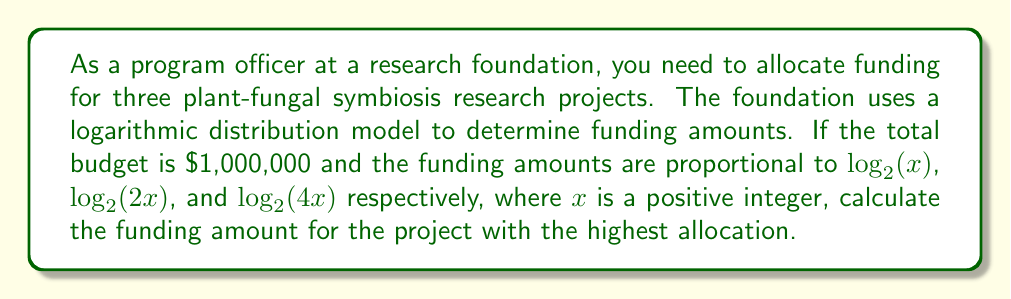Could you help me with this problem? Let's approach this step-by-step:

1) First, we need to set up equations based on the given information:
   Let $a$, $b$, and $c$ be the funding amounts for the three projects.
   
   $a \propto \log_2(x)$
   $b \propto \log_2(2x)$
   $c \propto \log_2(4x)$

2) We can write these proportions as equations:
   
   $a = k\log_2(x)$
   $b = k\log_2(2x)$
   $c = k\log_2(4x)$

   Where $k$ is a constant we need to determine.

3) We know that the total budget is $1,000,000, so:

   $a + b + c = 1,000,000$

4) Substituting our equations:

   $k\log_2(x) + k\log_2(2x) + k\log_2(4x) = 1,000,000$

5) Using logarithm properties:

   $k\log_2(x) + k(\log_2(x) + 1) + k(\log_2(x) + 2) = 1,000,000$

6) Simplifying:

   $k(3\log_2(x) + 3) = 1,000,000$

7) Factoring out $k$:

   $k(3\log_2(x) + 3) = 1,000,000$

8) The largest allocation will be for $c = k\log_2(4x)$, which simplifies to $k(\log_2(x) + 2)$

9) To find this, we need to solve for $k$:

   $k = \frac{1,000,000}{3\log_2(x) + 3}$

10) Substituting this into the equation for $c$:

    $c = \frac{1,000,000}{3\log_2(x) + 3} (\log_2(x) + 2)$

11) Simplifying:

    $c = \frac{1,000,000(\log_2(x) + 2)}{3\log_2(x) + 3}$

12) This fraction will be largest when $x$ is as small as possible (which is 1 in this case).

13) When $x = 1$, $\log_2(1) = 0$, so:

    $c = \frac{1,000,000(0 + 2)}{3(0) + 3} = \frac{2,000,000}{3} \approx 666,667$
Answer: $666,667 